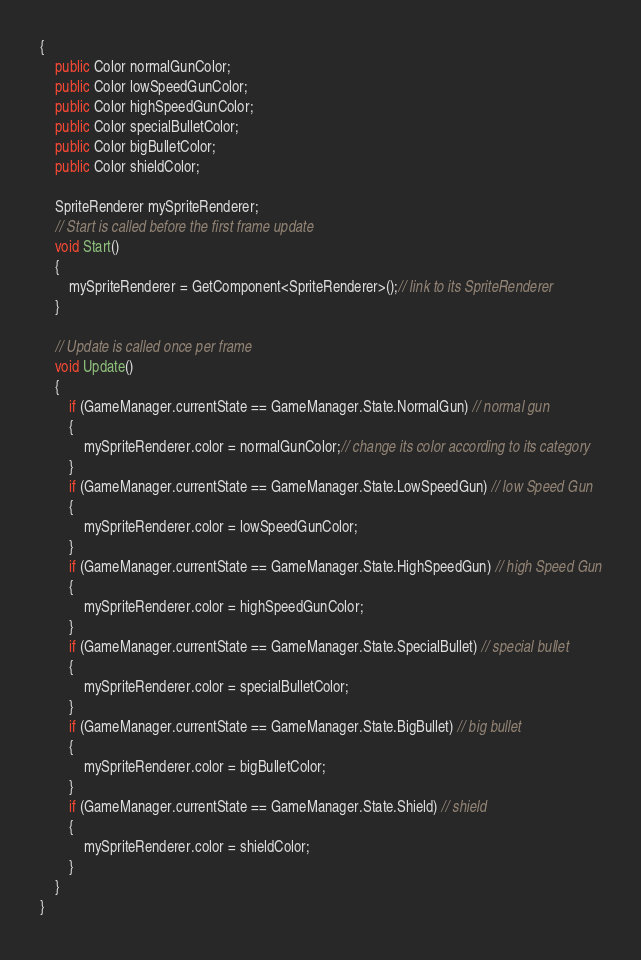<code> <loc_0><loc_0><loc_500><loc_500><_C#_>{
    public Color normalGunColor;
    public Color lowSpeedGunColor;
    public Color highSpeedGunColor;
    public Color specialBulletColor;
    public Color bigBulletColor;
    public Color shieldColor;

    SpriteRenderer mySpriteRenderer;
    // Start is called before the first frame update
    void Start()
    {
        mySpriteRenderer = GetComponent<SpriteRenderer>();// link to its SpriteRenderer
    }

    // Update is called once per frame
    void Update()
    {
        if (GameManager.currentState == GameManager.State.NormalGun) // normal gun
        {
            mySpriteRenderer.color = normalGunColor;// change its color according to its category
        }
        if (GameManager.currentState == GameManager.State.LowSpeedGun) // low Speed Gun
        {
            mySpriteRenderer.color = lowSpeedGunColor;
        }
        if (GameManager.currentState == GameManager.State.HighSpeedGun) // high Speed Gun
        {
            mySpriteRenderer.color = highSpeedGunColor;
        }
        if (GameManager.currentState == GameManager.State.SpecialBullet) // special bullet
        {
            mySpriteRenderer.color = specialBulletColor;
        }
        if (GameManager.currentState == GameManager.State.BigBullet) // big bullet
        {
            mySpriteRenderer.color = bigBulletColor;
        }
        if (GameManager.currentState == GameManager.State.Shield) // shield
        {
            mySpriteRenderer.color = shieldColor;
        }
    }
}
</code> 